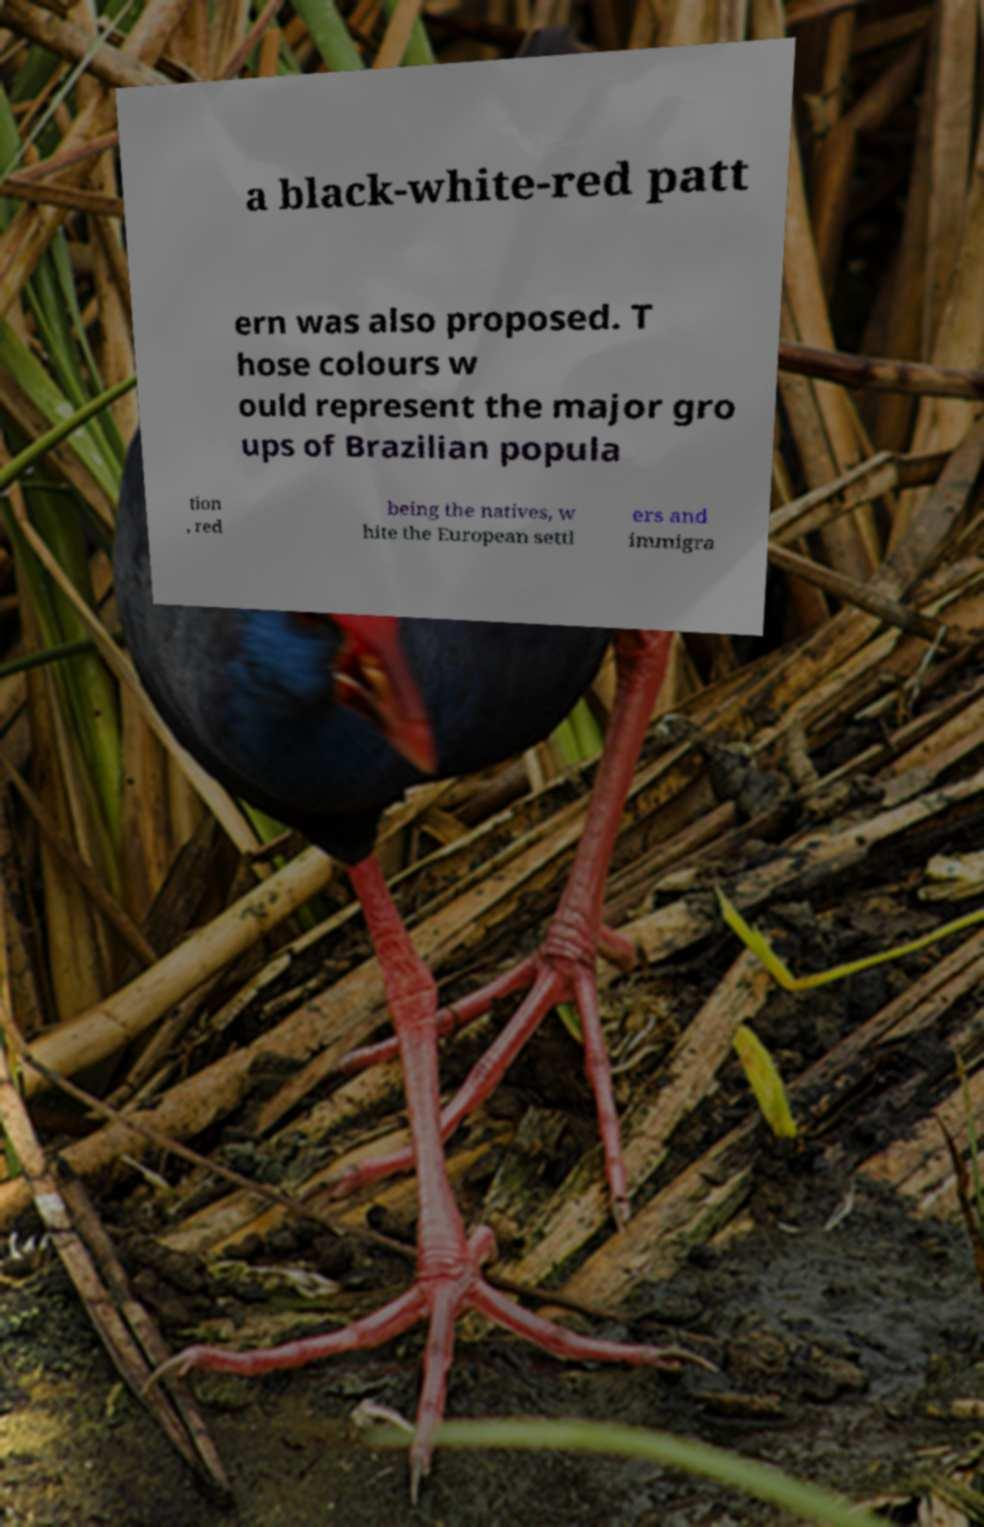Could you assist in decoding the text presented in this image and type it out clearly? a black-white-red patt ern was also proposed. T hose colours w ould represent the major gro ups of Brazilian popula tion , red being the natives, w hite the European settl ers and immigra 